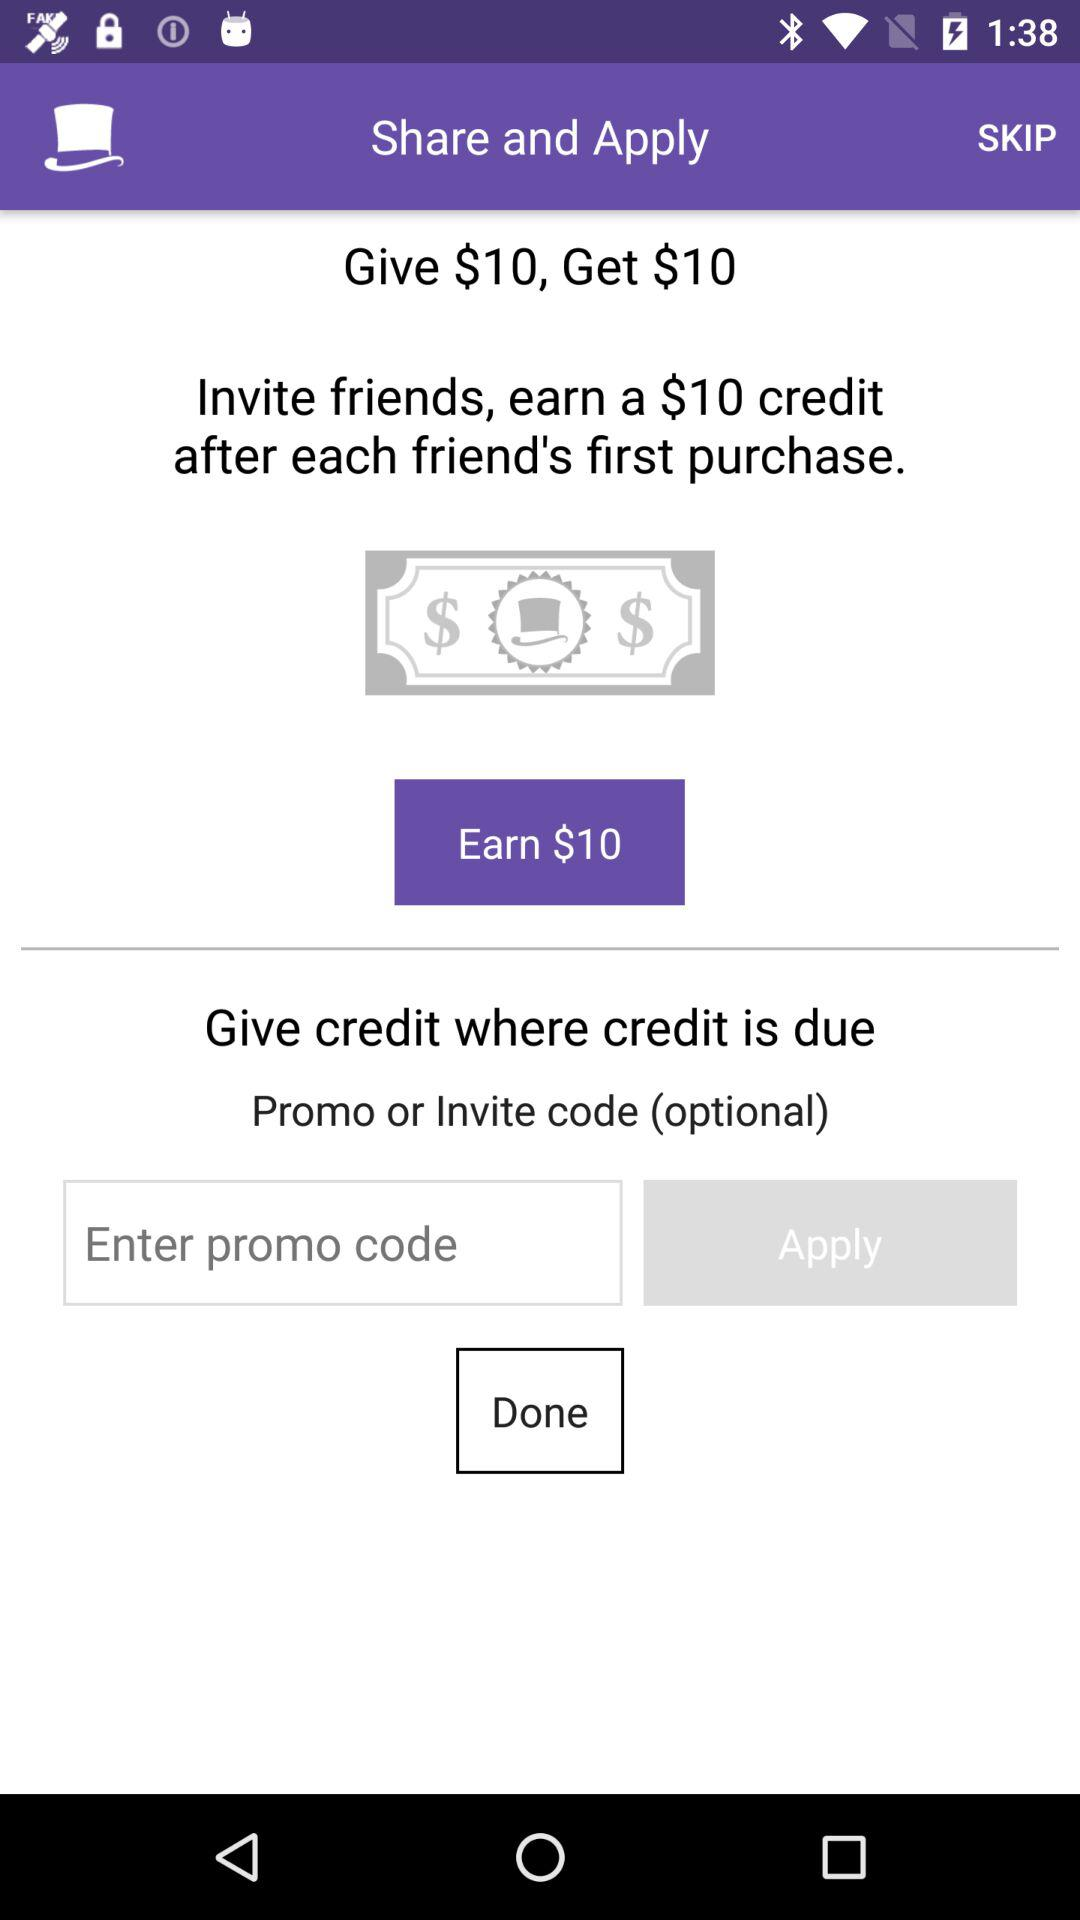How much will I get after every friend's first purchase? You will get $10 in credit. 